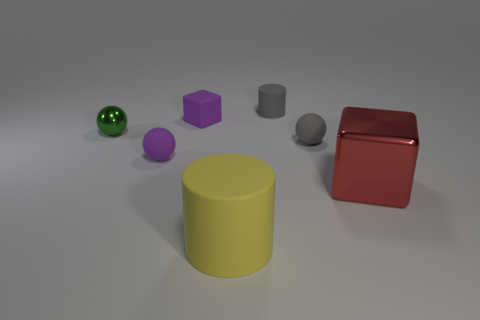Subtract all tiny rubber spheres. How many spheres are left? 1 Subtract 1 balls. How many balls are left? 2 Add 3 small cylinders. How many objects exist? 10 Add 5 tiny purple metallic objects. How many tiny purple metallic objects exist? 5 Subtract 0 green blocks. How many objects are left? 7 Subtract all blocks. How many objects are left? 5 Subtract all blue spheres. Subtract all blue blocks. How many spheres are left? 3 Subtract all gray objects. Subtract all brown shiny cubes. How many objects are left? 5 Add 3 big red metal blocks. How many big red metal blocks are left? 4 